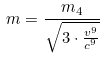Convert formula to latex. <formula><loc_0><loc_0><loc_500><loc_500>m = \frac { m _ { 4 } } { \sqrt { 3 \cdot \frac { v ^ { 9 } } { c ^ { 9 } } } }</formula> 